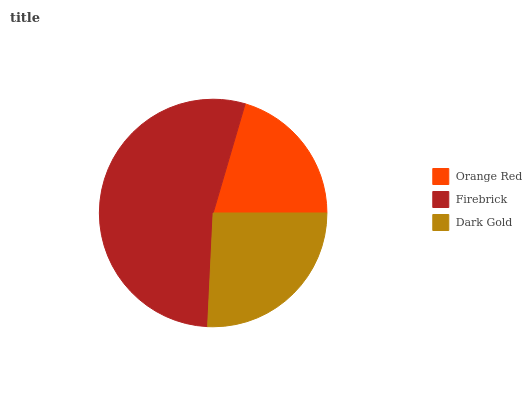Is Orange Red the minimum?
Answer yes or no. Yes. Is Firebrick the maximum?
Answer yes or no. Yes. Is Dark Gold the minimum?
Answer yes or no. No. Is Dark Gold the maximum?
Answer yes or no. No. Is Firebrick greater than Dark Gold?
Answer yes or no. Yes. Is Dark Gold less than Firebrick?
Answer yes or no. Yes. Is Dark Gold greater than Firebrick?
Answer yes or no. No. Is Firebrick less than Dark Gold?
Answer yes or no. No. Is Dark Gold the high median?
Answer yes or no. Yes. Is Dark Gold the low median?
Answer yes or no. Yes. Is Orange Red the high median?
Answer yes or no. No. Is Orange Red the low median?
Answer yes or no. No. 